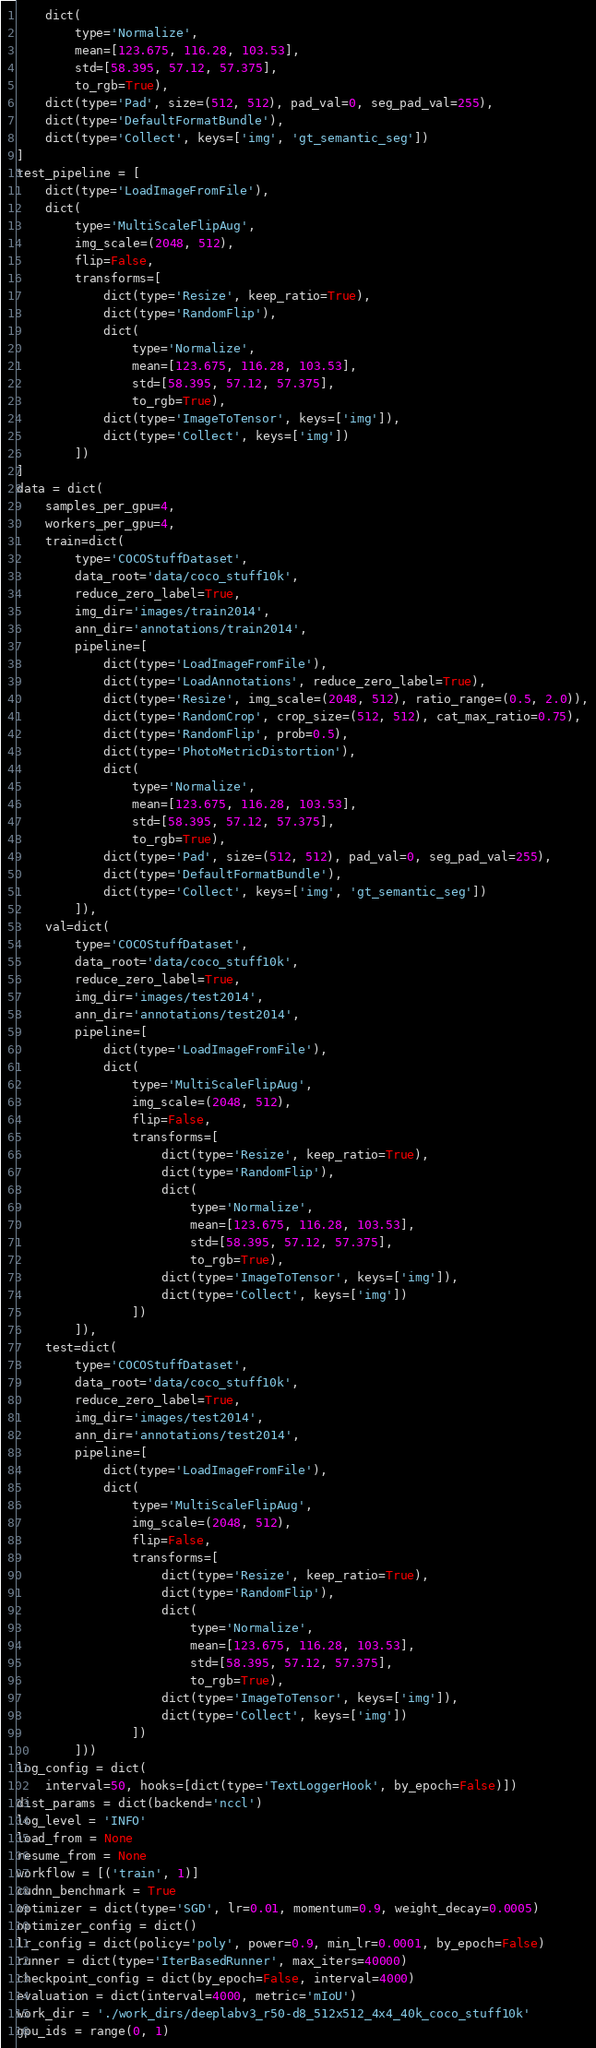Convert code to text. <code><loc_0><loc_0><loc_500><loc_500><_Python_>    dict(
        type='Normalize',
        mean=[123.675, 116.28, 103.53],
        std=[58.395, 57.12, 57.375],
        to_rgb=True),
    dict(type='Pad', size=(512, 512), pad_val=0, seg_pad_val=255),
    dict(type='DefaultFormatBundle'),
    dict(type='Collect', keys=['img', 'gt_semantic_seg'])
]
test_pipeline = [
    dict(type='LoadImageFromFile'),
    dict(
        type='MultiScaleFlipAug',
        img_scale=(2048, 512),
        flip=False,
        transforms=[
            dict(type='Resize', keep_ratio=True),
            dict(type='RandomFlip'),
            dict(
                type='Normalize',
                mean=[123.675, 116.28, 103.53],
                std=[58.395, 57.12, 57.375],
                to_rgb=True),
            dict(type='ImageToTensor', keys=['img']),
            dict(type='Collect', keys=['img'])
        ])
]
data = dict(
    samples_per_gpu=4,
    workers_per_gpu=4,
    train=dict(
        type='COCOStuffDataset',
        data_root='data/coco_stuff10k',
        reduce_zero_label=True,
        img_dir='images/train2014',
        ann_dir='annotations/train2014',
        pipeline=[
            dict(type='LoadImageFromFile'),
            dict(type='LoadAnnotations', reduce_zero_label=True),
            dict(type='Resize', img_scale=(2048, 512), ratio_range=(0.5, 2.0)),
            dict(type='RandomCrop', crop_size=(512, 512), cat_max_ratio=0.75),
            dict(type='RandomFlip', prob=0.5),
            dict(type='PhotoMetricDistortion'),
            dict(
                type='Normalize',
                mean=[123.675, 116.28, 103.53],
                std=[58.395, 57.12, 57.375],
                to_rgb=True),
            dict(type='Pad', size=(512, 512), pad_val=0, seg_pad_val=255),
            dict(type='DefaultFormatBundle'),
            dict(type='Collect', keys=['img', 'gt_semantic_seg'])
        ]),
    val=dict(
        type='COCOStuffDataset',
        data_root='data/coco_stuff10k',
        reduce_zero_label=True,
        img_dir='images/test2014',
        ann_dir='annotations/test2014',
        pipeline=[
            dict(type='LoadImageFromFile'),
            dict(
                type='MultiScaleFlipAug',
                img_scale=(2048, 512),
                flip=False,
                transforms=[
                    dict(type='Resize', keep_ratio=True),
                    dict(type='RandomFlip'),
                    dict(
                        type='Normalize',
                        mean=[123.675, 116.28, 103.53],
                        std=[58.395, 57.12, 57.375],
                        to_rgb=True),
                    dict(type='ImageToTensor', keys=['img']),
                    dict(type='Collect', keys=['img'])
                ])
        ]),
    test=dict(
        type='COCOStuffDataset',
        data_root='data/coco_stuff10k',
        reduce_zero_label=True,
        img_dir='images/test2014',
        ann_dir='annotations/test2014',
        pipeline=[
            dict(type='LoadImageFromFile'),
            dict(
                type='MultiScaleFlipAug',
                img_scale=(2048, 512),
                flip=False,
                transforms=[
                    dict(type='Resize', keep_ratio=True),
                    dict(type='RandomFlip'),
                    dict(
                        type='Normalize',
                        mean=[123.675, 116.28, 103.53],
                        std=[58.395, 57.12, 57.375],
                        to_rgb=True),
                    dict(type='ImageToTensor', keys=['img']),
                    dict(type='Collect', keys=['img'])
                ])
        ]))
log_config = dict(
    interval=50, hooks=[dict(type='TextLoggerHook', by_epoch=False)])
dist_params = dict(backend='nccl')
log_level = 'INFO'
load_from = None
resume_from = None
workflow = [('train', 1)]
cudnn_benchmark = True
optimizer = dict(type='SGD', lr=0.01, momentum=0.9, weight_decay=0.0005)
optimizer_config = dict()
lr_config = dict(policy='poly', power=0.9, min_lr=0.0001, by_epoch=False)
runner = dict(type='IterBasedRunner', max_iters=40000)
checkpoint_config = dict(by_epoch=False, interval=4000)
evaluation = dict(interval=4000, metric='mIoU')
work_dir = './work_dirs/deeplabv3_r50-d8_512x512_4x4_40k_coco_stuff10k'
gpu_ids = range(0, 1)
</code> 